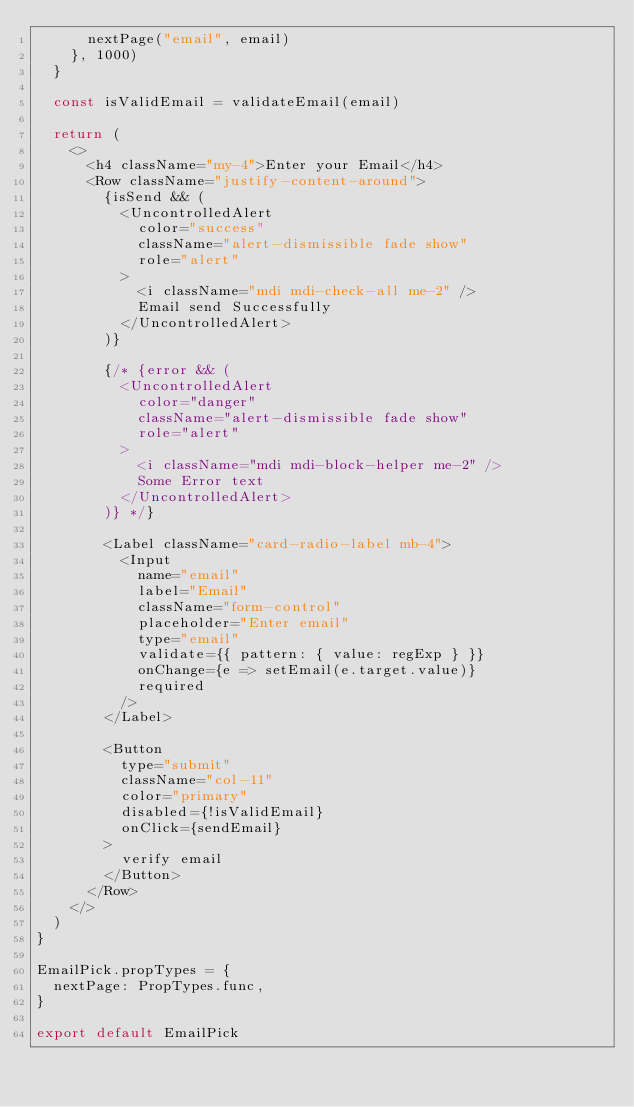<code> <loc_0><loc_0><loc_500><loc_500><_JavaScript_>      nextPage("email", email)
    }, 1000)
  }

  const isValidEmail = validateEmail(email)

  return (
    <>
      <h4 className="my-4">Enter your Email</h4>
      <Row className="justify-content-around">
        {isSend && (
          <UncontrolledAlert
            color="success"
            className="alert-dismissible fade show"
            role="alert"
          >
            <i className="mdi mdi-check-all me-2" />
            Email send Successfully
          </UncontrolledAlert>
        )}

        {/* {error && (
          <UncontrolledAlert
            color="danger"
            className="alert-dismissible fade show"
            role="alert"
          >
            <i className="mdi mdi-block-helper me-2" />
            Some Error text
          </UncontrolledAlert>
        )} */}

        <Label className="card-radio-label mb-4">
          <Input
            name="email"
            label="Email"
            className="form-control"
            placeholder="Enter email"
            type="email"
            validate={{ pattern: { value: regExp } }}
            onChange={e => setEmail(e.target.value)}
            required
          />
        </Label>

        <Button
          type="submit"
          className="col-11"
          color="primary"
          disabled={!isValidEmail}
          onClick={sendEmail}
        >
          verify email
        </Button>
      </Row>
    </>
  )
}

EmailPick.propTypes = {
  nextPage: PropTypes.func,
}

export default EmailPick
</code> 